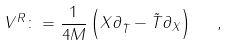Convert formula to latex. <formula><loc_0><loc_0><loc_500><loc_500>V ^ { R } \colon = \frac { 1 } { 4 M } \left ( X \partial _ { \tilde { T } } - { \tilde { T } } \partial _ { X } \right ) \ \ ,</formula> 